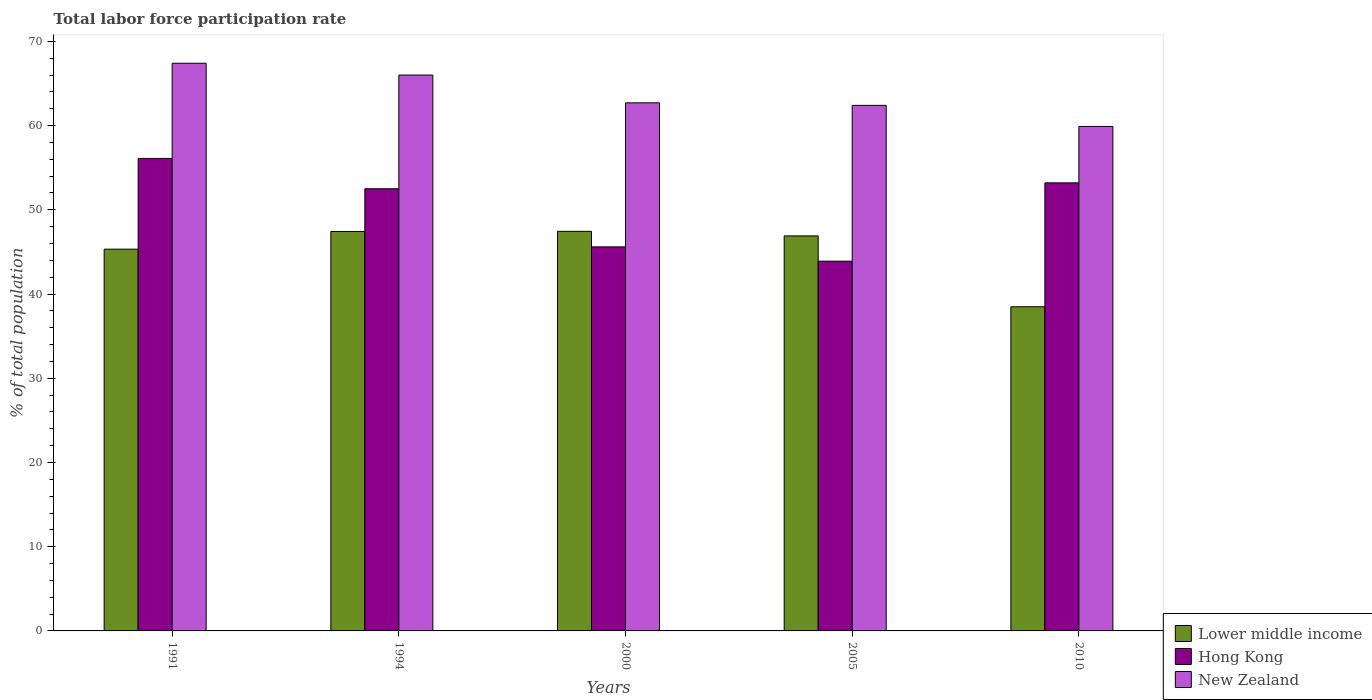Are the number of bars on each tick of the X-axis equal?
Provide a succinct answer. Yes. What is the total labor force participation rate in Lower middle income in 1994?
Make the answer very short. 47.43. Across all years, what is the maximum total labor force participation rate in New Zealand?
Provide a short and direct response. 67.4. Across all years, what is the minimum total labor force participation rate in Hong Kong?
Provide a succinct answer. 43.9. In which year was the total labor force participation rate in New Zealand minimum?
Offer a very short reply. 2010. What is the total total labor force participation rate in Hong Kong in the graph?
Keep it short and to the point. 251.3. What is the difference between the total labor force participation rate in Lower middle income in 1991 and that in 2000?
Make the answer very short. -2.12. What is the difference between the total labor force participation rate in Lower middle income in 2000 and the total labor force participation rate in New Zealand in 1994?
Offer a very short reply. -18.56. What is the average total labor force participation rate in Lower middle income per year?
Provide a succinct answer. 45.12. In the year 2000, what is the difference between the total labor force participation rate in Hong Kong and total labor force participation rate in New Zealand?
Provide a succinct answer. -17.1. What is the ratio of the total labor force participation rate in New Zealand in 1994 to that in 2010?
Keep it short and to the point. 1.1. Is the total labor force participation rate in Hong Kong in 1994 less than that in 2005?
Give a very brief answer. No. Is the difference between the total labor force participation rate in Hong Kong in 1991 and 2010 greater than the difference between the total labor force participation rate in New Zealand in 1991 and 2010?
Provide a succinct answer. No. What is the difference between the highest and the second highest total labor force participation rate in New Zealand?
Offer a very short reply. 1.4. What is the difference between the highest and the lowest total labor force participation rate in New Zealand?
Offer a terse response. 7.5. In how many years, is the total labor force participation rate in New Zealand greater than the average total labor force participation rate in New Zealand taken over all years?
Provide a succinct answer. 2. Is the sum of the total labor force participation rate in Hong Kong in 1994 and 2005 greater than the maximum total labor force participation rate in Lower middle income across all years?
Give a very brief answer. Yes. What does the 3rd bar from the left in 2005 represents?
Keep it short and to the point. New Zealand. What does the 1st bar from the right in 2010 represents?
Keep it short and to the point. New Zealand. How many bars are there?
Your response must be concise. 15. What is the difference between two consecutive major ticks on the Y-axis?
Make the answer very short. 10. Are the values on the major ticks of Y-axis written in scientific E-notation?
Give a very brief answer. No. Does the graph contain any zero values?
Offer a terse response. No. Does the graph contain grids?
Ensure brevity in your answer.  No. What is the title of the graph?
Offer a very short reply. Total labor force participation rate. What is the label or title of the X-axis?
Provide a succinct answer. Years. What is the label or title of the Y-axis?
Your answer should be compact. % of total population. What is the % of total population of Lower middle income in 1991?
Offer a terse response. 45.33. What is the % of total population in Hong Kong in 1991?
Your answer should be very brief. 56.1. What is the % of total population of New Zealand in 1991?
Keep it short and to the point. 67.4. What is the % of total population of Lower middle income in 1994?
Provide a short and direct response. 47.43. What is the % of total population in Hong Kong in 1994?
Provide a short and direct response. 52.5. What is the % of total population in New Zealand in 1994?
Keep it short and to the point. 66. What is the % of total population of Lower middle income in 2000?
Offer a very short reply. 47.44. What is the % of total population in Hong Kong in 2000?
Offer a very short reply. 45.6. What is the % of total population in New Zealand in 2000?
Your response must be concise. 62.7. What is the % of total population in Lower middle income in 2005?
Your answer should be compact. 46.9. What is the % of total population of Hong Kong in 2005?
Keep it short and to the point. 43.9. What is the % of total population of New Zealand in 2005?
Ensure brevity in your answer.  62.4. What is the % of total population of Lower middle income in 2010?
Your answer should be compact. 38.49. What is the % of total population of Hong Kong in 2010?
Provide a succinct answer. 53.2. What is the % of total population in New Zealand in 2010?
Keep it short and to the point. 59.9. Across all years, what is the maximum % of total population of Lower middle income?
Your answer should be compact. 47.44. Across all years, what is the maximum % of total population in Hong Kong?
Offer a terse response. 56.1. Across all years, what is the maximum % of total population of New Zealand?
Give a very brief answer. 67.4. Across all years, what is the minimum % of total population of Lower middle income?
Provide a short and direct response. 38.49. Across all years, what is the minimum % of total population of Hong Kong?
Make the answer very short. 43.9. Across all years, what is the minimum % of total population of New Zealand?
Give a very brief answer. 59.9. What is the total % of total population of Lower middle income in the graph?
Give a very brief answer. 225.59. What is the total % of total population of Hong Kong in the graph?
Make the answer very short. 251.3. What is the total % of total population in New Zealand in the graph?
Your response must be concise. 318.4. What is the difference between the % of total population in Lower middle income in 1991 and that in 1994?
Ensure brevity in your answer.  -2.1. What is the difference between the % of total population in Hong Kong in 1991 and that in 1994?
Provide a short and direct response. 3.6. What is the difference between the % of total population in Lower middle income in 1991 and that in 2000?
Ensure brevity in your answer.  -2.12. What is the difference between the % of total population in Hong Kong in 1991 and that in 2000?
Your answer should be compact. 10.5. What is the difference between the % of total population of Lower middle income in 1991 and that in 2005?
Provide a short and direct response. -1.57. What is the difference between the % of total population in Hong Kong in 1991 and that in 2005?
Make the answer very short. 12.2. What is the difference between the % of total population in New Zealand in 1991 and that in 2005?
Offer a terse response. 5. What is the difference between the % of total population in Lower middle income in 1991 and that in 2010?
Provide a succinct answer. 6.84. What is the difference between the % of total population in New Zealand in 1991 and that in 2010?
Make the answer very short. 7.5. What is the difference between the % of total population of Lower middle income in 1994 and that in 2000?
Keep it short and to the point. -0.02. What is the difference between the % of total population of Hong Kong in 1994 and that in 2000?
Your response must be concise. 6.9. What is the difference between the % of total population in New Zealand in 1994 and that in 2000?
Offer a very short reply. 3.3. What is the difference between the % of total population in Lower middle income in 1994 and that in 2005?
Provide a short and direct response. 0.53. What is the difference between the % of total population of Lower middle income in 1994 and that in 2010?
Give a very brief answer. 8.94. What is the difference between the % of total population in Lower middle income in 2000 and that in 2005?
Provide a short and direct response. 0.54. What is the difference between the % of total population in Hong Kong in 2000 and that in 2005?
Provide a succinct answer. 1.7. What is the difference between the % of total population in New Zealand in 2000 and that in 2005?
Offer a terse response. 0.3. What is the difference between the % of total population of Lower middle income in 2000 and that in 2010?
Provide a succinct answer. 8.96. What is the difference between the % of total population in Lower middle income in 2005 and that in 2010?
Your answer should be compact. 8.41. What is the difference between the % of total population of New Zealand in 2005 and that in 2010?
Your response must be concise. 2.5. What is the difference between the % of total population of Lower middle income in 1991 and the % of total population of Hong Kong in 1994?
Your answer should be compact. -7.17. What is the difference between the % of total population of Lower middle income in 1991 and the % of total population of New Zealand in 1994?
Ensure brevity in your answer.  -20.67. What is the difference between the % of total population in Lower middle income in 1991 and the % of total population in Hong Kong in 2000?
Make the answer very short. -0.27. What is the difference between the % of total population of Lower middle income in 1991 and the % of total population of New Zealand in 2000?
Keep it short and to the point. -17.37. What is the difference between the % of total population in Lower middle income in 1991 and the % of total population in Hong Kong in 2005?
Your answer should be very brief. 1.43. What is the difference between the % of total population in Lower middle income in 1991 and the % of total population in New Zealand in 2005?
Your response must be concise. -17.07. What is the difference between the % of total population of Hong Kong in 1991 and the % of total population of New Zealand in 2005?
Give a very brief answer. -6.3. What is the difference between the % of total population in Lower middle income in 1991 and the % of total population in Hong Kong in 2010?
Offer a very short reply. -7.87. What is the difference between the % of total population of Lower middle income in 1991 and the % of total population of New Zealand in 2010?
Ensure brevity in your answer.  -14.57. What is the difference between the % of total population in Hong Kong in 1991 and the % of total population in New Zealand in 2010?
Provide a short and direct response. -3.8. What is the difference between the % of total population of Lower middle income in 1994 and the % of total population of Hong Kong in 2000?
Offer a terse response. 1.83. What is the difference between the % of total population of Lower middle income in 1994 and the % of total population of New Zealand in 2000?
Offer a very short reply. -15.27. What is the difference between the % of total population in Lower middle income in 1994 and the % of total population in Hong Kong in 2005?
Keep it short and to the point. 3.53. What is the difference between the % of total population of Lower middle income in 1994 and the % of total population of New Zealand in 2005?
Make the answer very short. -14.97. What is the difference between the % of total population in Lower middle income in 1994 and the % of total population in Hong Kong in 2010?
Keep it short and to the point. -5.77. What is the difference between the % of total population of Lower middle income in 1994 and the % of total population of New Zealand in 2010?
Your answer should be compact. -12.47. What is the difference between the % of total population of Hong Kong in 1994 and the % of total population of New Zealand in 2010?
Keep it short and to the point. -7.4. What is the difference between the % of total population in Lower middle income in 2000 and the % of total population in Hong Kong in 2005?
Keep it short and to the point. 3.54. What is the difference between the % of total population of Lower middle income in 2000 and the % of total population of New Zealand in 2005?
Your answer should be very brief. -14.96. What is the difference between the % of total population of Hong Kong in 2000 and the % of total population of New Zealand in 2005?
Make the answer very short. -16.8. What is the difference between the % of total population of Lower middle income in 2000 and the % of total population of Hong Kong in 2010?
Give a very brief answer. -5.76. What is the difference between the % of total population of Lower middle income in 2000 and the % of total population of New Zealand in 2010?
Give a very brief answer. -12.46. What is the difference between the % of total population of Hong Kong in 2000 and the % of total population of New Zealand in 2010?
Your answer should be compact. -14.3. What is the difference between the % of total population in Lower middle income in 2005 and the % of total population in Hong Kong in 2010?
Your answer should be compact. -6.3. What is the difference between the % of total population in Lower middle income in 2005 and the % of total population in New Zealand in 2010?
Make the answer very short. -13. What is the difference between the % of total population in Hong Kong in 2005 and the % of total population in New Zealand in 2010?
Offer a terse response. -16. What is the average % of total population in Lower middle income per year?
Your answer should be very brief. 45.12. What is the average % of total population in Hong Kong per year?
Keep it short and to the point. 50.26. What is the average % of total population of New Zealand per year?
Offer a terse response. 63.68. In the year 1991, what is the difference between the % of total population of Lower middle income and % of total population of Hong Kong?
Give a very brief answer. -10.77. In the year 1991, what is the difference between the % of total population of Lower middle income and % of total population of New Zealand?
Give a very brief answer. -22.07. In the year 1994, what is the difference between the % of total population of Lower middle income and % of total population of Hong Kong?
Provide a succinct answer. -5.07. In the year 1994, what is the difference between the % of total population of Lower middle income and % of total population of New Zealand?
Ensure brevity in your answer.  -18.57. In the year 1994, what is the difference between the % of total population in Hong Kong and % of total population in New Zealand?
Ensure brevity in your answer.  -13.5. In the year 2000, what is the difference between the % of total population in Lower middle income and % of total population in Hong Kong?
Offer a very short reply. 1.84. In the year 2000, what is the difference between the % of total population in Lower middle income and % of total population in New Zealand?
Provide a succinct answer. -15.26. In the year 2000, what is the difference between the % of total population in Hong Kong and % of total population in New Zealand?
Your answer should be very brief. -17.1. In the year 2005, what is the difference between the % of total population of Lower middle income and % of total population of Hong Kong?
Provide a succinct answer. 3. In the year 2005, what is the difference between the % of total population of Lower middle income and % of total population of New Zealand?
Your answer should be compact. -15.5. In the year 2005, what is the difference between the % of total population in Hong Kong and % of total population in New Zealand?
Your answer should be compact. -18.5. In the year 2010, what is the difference between the % of total population in Lower middle income and % of total population in Hong Kong?
Your answer should be compact. -14.71. In the year 2010, what is the difference between the % of total population of Lower middle income and % of total population of New Zealand?
Your answer should be compact. -21.41. In the year 2010, what is the difference between the % of total population in Hong Kong and % of total population in New Zealand?
Provide a short and direct response. -6.7. What is the ratio of the % of total population of Lower middle income in 1991 to that in 1994?
Give a very brief answer. 0.96. What is the ratio of the % of total population in Hong Kong in 1991 to that in 1994?
Your answer should be compact. 1.07. What is the ratio of the % of total population of New Zealand in 1991 to that in 1994?
Provide a succinct answer. 1.02. What is the ratio of the % of total population in Lower middle income in 1991 to that in 2000?
Ensure brevity in your answer.  0.96. What is the ratio of the % of total population of Hong Kong in 1991 to that in 2000?
Provide a succinct answer. 1.23. What is the ratio of the % of total population in New Zealand in 1991 to that in 2000?
Your response must be concise. 1.07. What is the ratio of the % of total population of Lower middle income in 1991 to that in 2005?
Make the answer very short. 0.97. What is the ratio of the % of total population of Hong Kong in 1991 to that in 2005?
Offer a terse response. 1.28. What is the ratio of the % of total population in New Zealand in 1991 to that in 2005?
Your response must be concise. 1.08. What is the ratio of the % of total population of Lower middle income in 1991 to that in 2010?
Offer a terse response. 1.18. What is the ratio of the % of total population of Hong Kong in 1991 to that in 2010?
Provide a succinct answer. 1.05. What is the ratio of the % of total population in New Zealand in 1991 to that in 2010?
Your answer should be compact. 1.13. What is the ratio of the % of total population of Lower middle income in 1994 to that in 2000?
Ensure brevity in your answer.  1. What is the ratio of the % of total population of Hong Kong in 1994 to that in 2000?
Your answer should be very brief. 1.15. What is the ratio of the % of total population in New Zealand in 1994 to that in 2000?
Ensure brevity in your answer.  1.05. What is the ratio of the % of total population of Lower middle income in 1994 to that in 2005?
Provide a short and direct response. 1.01. What is the ratio of the % of total population of Hong Kong in 1994 to that in 2005?
Give a very brief answer. 1.2. What is the ratio of the % of total population in New Zealand in 1994 to that in 2005?
Keep it short and to the point. 1.06. What is the ratio of the % of total population in Lower middle income in 1994 to that in 2010?
Your answer should be very brief. 1.23. What is the ratio of the % of total population in Hong Kong in 1994 to that in 2010?
Offer a very short reply. 0.99. What is the ratio of the % of total population in New Zealand in 1994 to that in 2010?
Offer a very short reply. 1.1. What is the ratio of the % of total population in Lower middle income in 2000 to that in 2005?
Your response must be concise. 1.01. What is the ratio of the % of total population of Hong Kong in 2000 to that in 2005?
Your answer should be very brief. 1.04. What is the ratio of the % of total population of Lower middle income in 2000 to that in 2010?
Ensure brevity in your answer.  1.23. What is the ratio of the % of total population of Hong Kong in 2000 to that in 2010?
Your answer should be very brief. 0.86. What is the ratio of the % of total population of New Zealand in 2000 to that in 2010?
Offer a very short reply. 1.05. What is the ratio of the % of total population of Lower middle income in 2005 to that in 2010?
Ensure brevity in your answer.  1.22. What is the ratio of the % of total population of Hong Kong in 2005 to that in 2010?
Keep it short and to the point. 0.83. What is the ratio of the % of total population in New Zealand in 2005 to that in 2010?
Ensure brevity in your answer.  1.04. What is the difference between the highest and the second highest % of total population of Lower middle income?
Offer a very short reply. 0.02. What is the difference between the highest and the lowest % of total population in Lower middle income?
Provide a short and direct response. 8.96. 